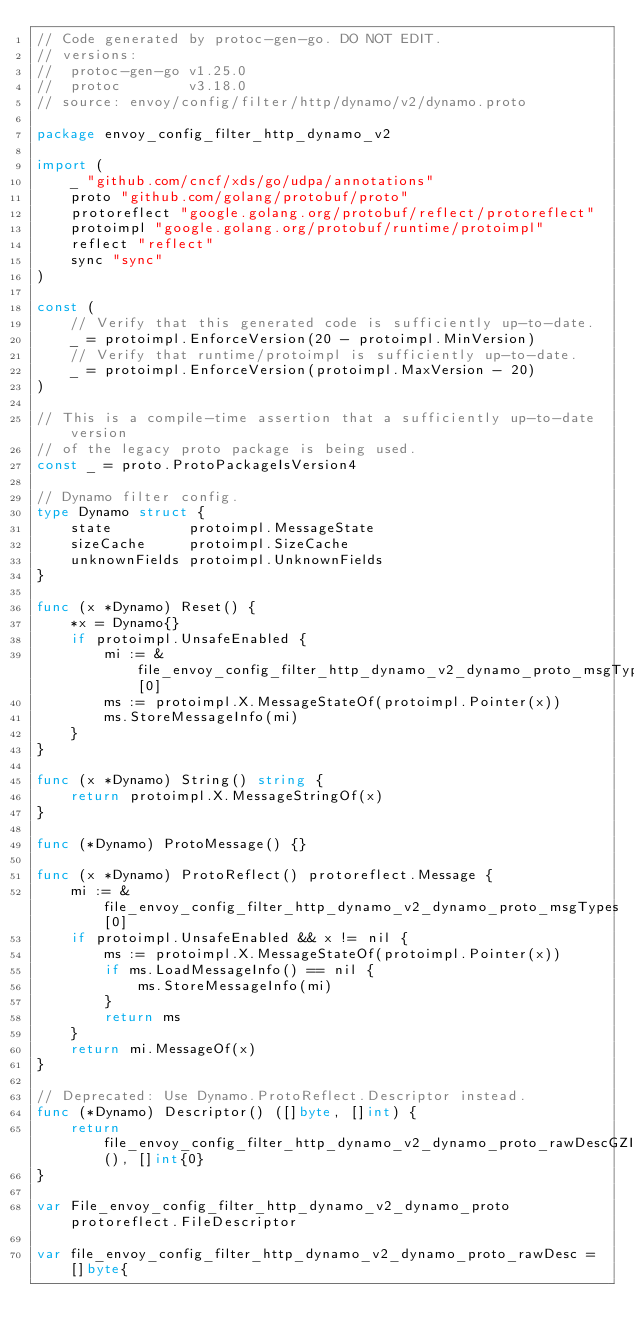<code> <loc_0><loc_0><loc_500><loc_500><_Go_>// Code generated by protoc-gen-go. DO NOT EDIT.
// versions:
// 	protoc-gen-go v1.25.0
// 	protoc        v3.18.0
// source: envoy/config/filter/http/dynamo/v2/dynamo.proto

package envoy_config_filter_http_dynamo_v2

import (
	_ "github.com/cncf/xds/go/udpa/annotations"
	proto "github.com/golang/protobuf/proto"
	protoreflect "google.golang.org/protobuf/reflect/protoreflect"
	protoimpl "google.golang.org/protobuf/runtime/protoimpl"
	reflect "reflect"
	sync "sync"
)

const (
	// Verify that this generated code is sufficiently up-to-date.
	_ = protoimpl.EnforceVersion(20 - protoimpl.MinVersion)
	// Verify that runtime/protoimpl is sufficiently up-to-date.
	_ = protoimpl.EnforceVersion(protoimpl.MaxVersion - 20)
)

// This is a compile-time assertion that a sufficiently up-to-date version
// of the legacy proto package is being used.
const _ = proto.ProtoPackageIsVersion4

// Dynamo filter config.
type Dynamo struct {
	state         protoimpl.MessageState
	sizeCache     protoimpl.SizeCache
	unknownFields protoimpl.UnknownFields
}

func (x *Dynamo) Reset() {
	*x = Dynamo{}
	if protoimpl.UnsafeEnabled {
		mi := &file_envoy_config_filter_http_dynamo_v2_dynamo_proto_msgTypes[0]
		ms := protoimpl.X.MessageStateOf(protoimpl.Pointer(x))
		ms.StoreMessageInfo(mi)
	}
}

func (x *Dynamo) String() string {
	return protoimpl.X.MessageStringOf(x)
}

func (*Dynamo) ProtoMessage() {}

func (x *Dynamo) ProtoReflect() protoreflect.Message {
	mi := &file_envoy_config_filter_http_dynamo_v2_dynamo_proto_msgTypes[0]
	if protoimpl.UnsafeEnabled && x != nil {
		ms := protoimpl.X.MessageStateOf(protoimpl.Pointer(x))
		if ms.LoadMessageInfo() == nil {
			ms.StoreMessageInfo(mi)
		}
		return ms
	}
	return mi.MessageOf(x)
}

// Deprecated: Use Dynamo.ProtoReflect.Descriptor instead.
func (*Dynamo) Descriptor() ([]byte, []int) {
	return file_envoy_config_filter_http_dynamo_v2_dynamo_proto_rawDescGZIP(), []int{0}
}

var File_envoy_config_filter_http_dynamo_v2_dynamo_proto protoreflect.FileDescriptor

var file_envoy_config_filter_http_dynamo_v2_dynamo_proto_rawDesc = []byte{</code> 